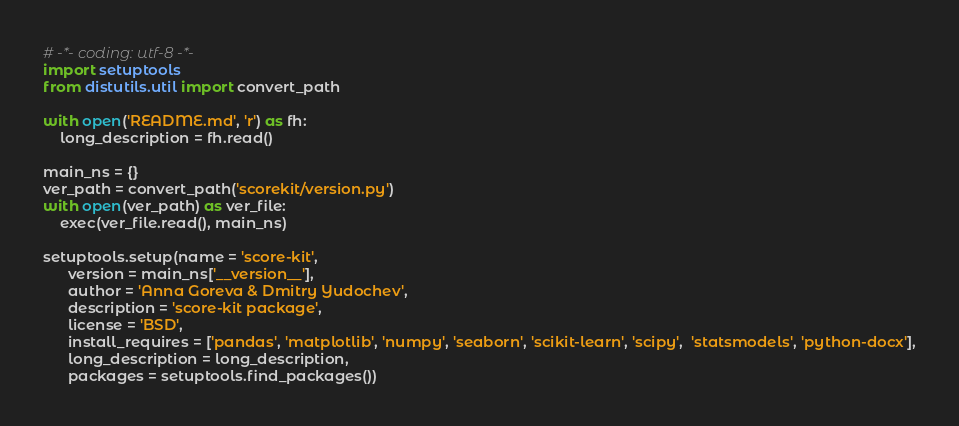<code> <loc_0><loc_0><loc_500><loc_500><_Python_># -*- coding: utf-8 -*-
import setuptools
from distutils.util import convert_path

with open('README.md', 'r') as fh:
    long_description = fh.read()

main_ns = {}
ver_path = convert_path('scorekit/version.py')
with open(ver_path) as ver_file:
    exec(ver_file.read(), main_ns)

setuptools.setup(name = 'score-kit',
      version = main_ns['__version__'],
      author = 'Anna Goreva & Dmitry Yudochev',
      description = 'score-kit package',
      license = 'BSD',
      install_requires = ['pandas', 'matplotlib', 'numpy', 'seaborn', 'scikit-learn', 'scipy',  'statsmodels', 'python-docx'],
      long_description = long_description,
      packages = setuptools.find_packages())
</code> 